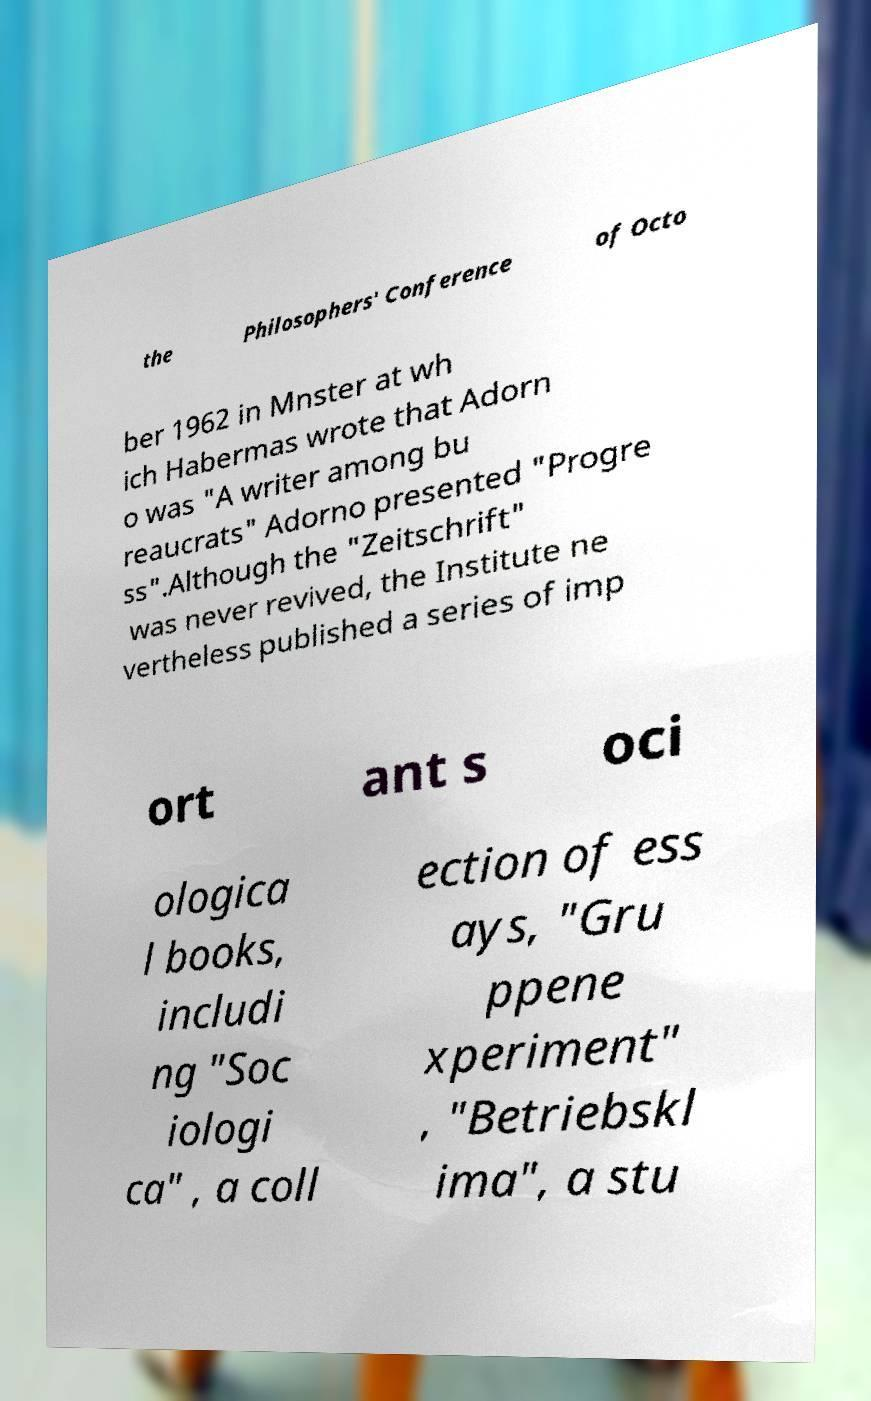Can you accurately transcribe the text from the provided image for me? the Philosophers' Conference of Octo ber 1962 in Mnster at wh ich Habermas wrote that Adorn o was "A writer among bu reaucrats" Adorno presented "Progre ss".Although the "Zeitschrift" was never revived, the Institute ne vertheless published a series of imp ort ant s oci ologica l books, includi ng "Soc iologi ca" , a coll ection of ess ays, "Gru ppene xperiment" , "Betriebskl ima", a stu 